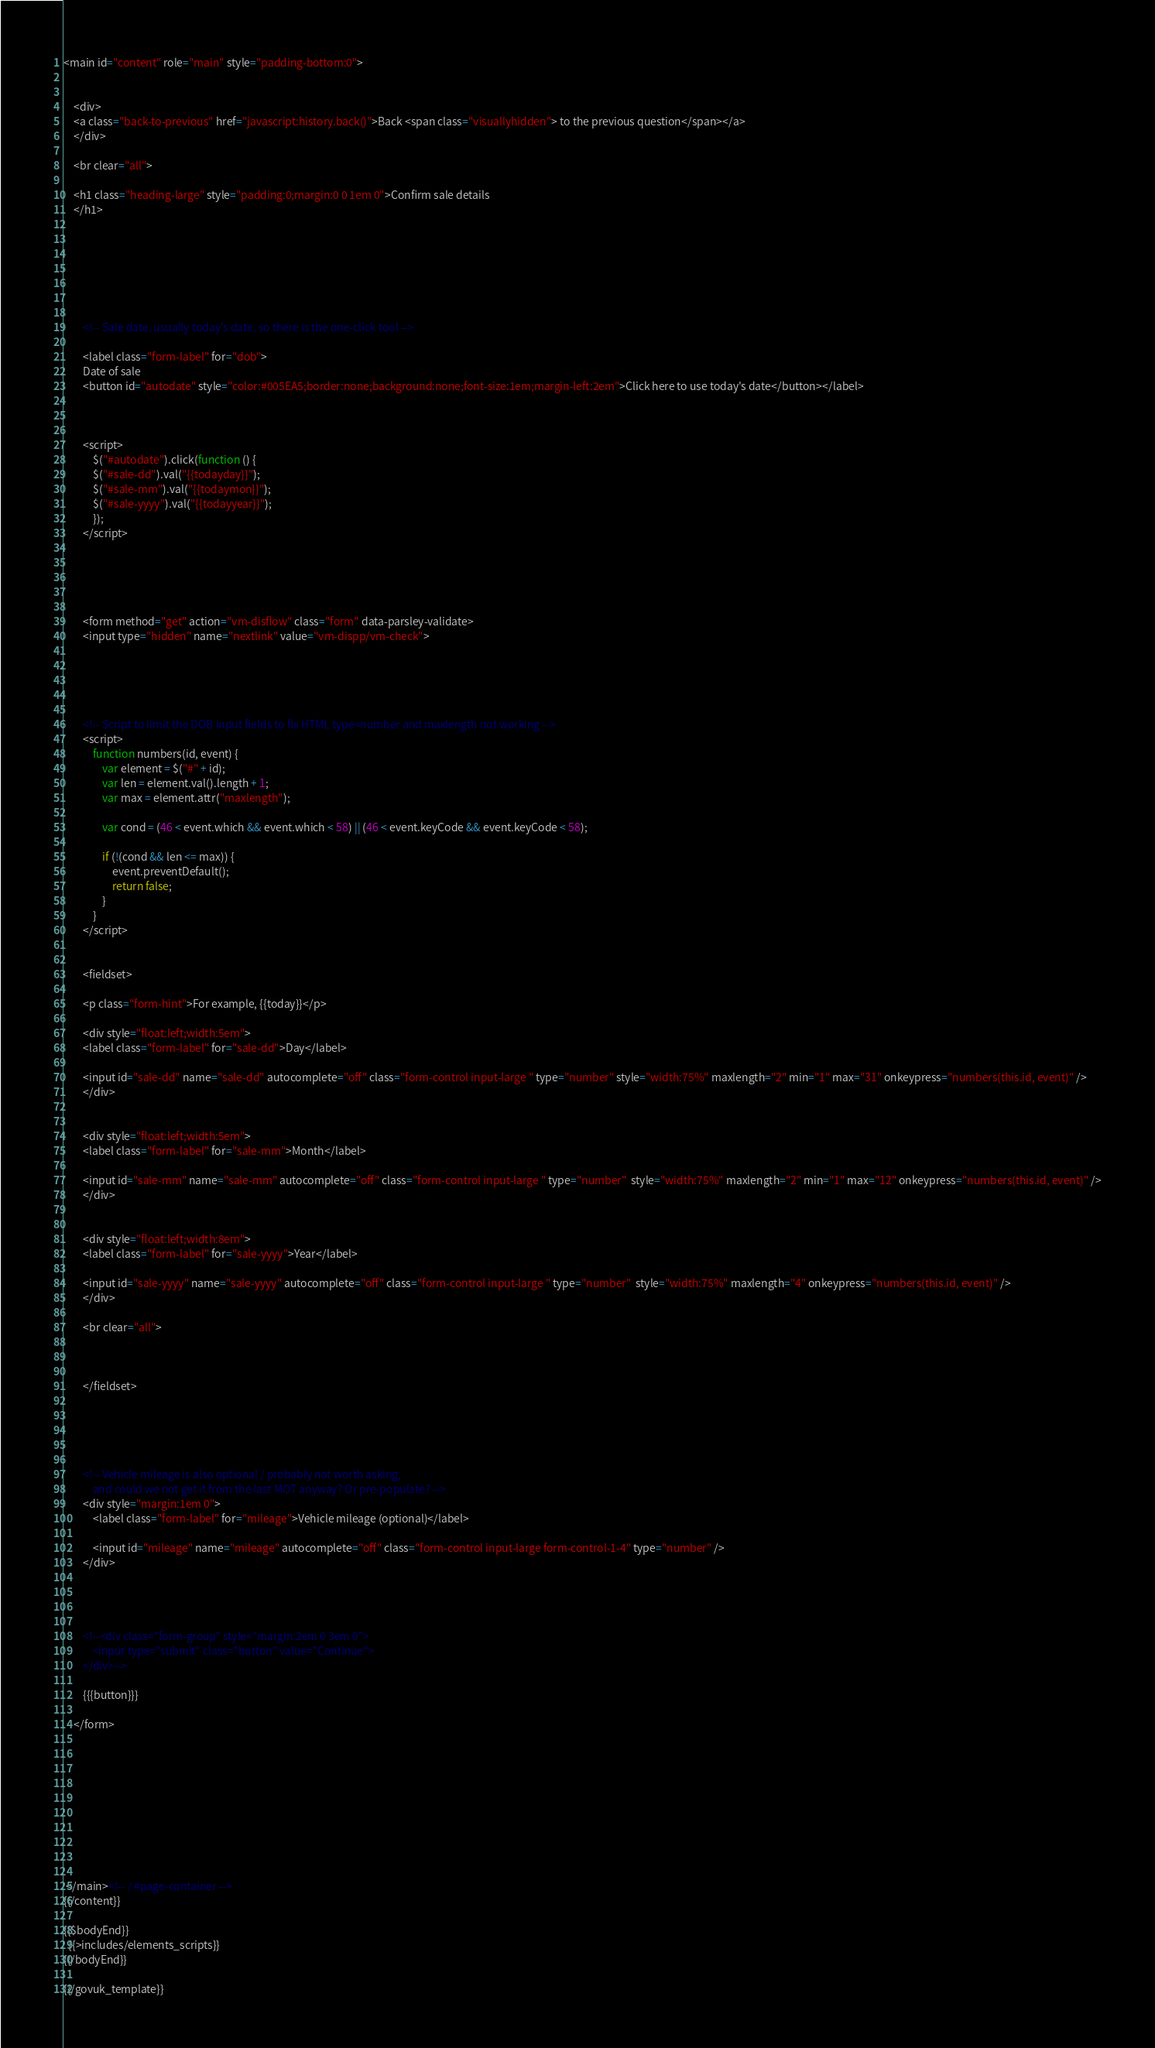<code> <loc_0><loc_0><loc_500><loc_500><_HTML_><main id="content" role="main" style="padding-bottom:0">


	<div>
	<a class="back-to-previous" href="javascript:history.back()">Back <span class="visuallyhidden"> to the previous question</span></a>
	</div>

	<br clear="all">

	<h1 class="heading-large" style="padding:0;margin:0 0 1em 0">Confirm sale details
	</h1>







		<!-- Sale date, usually today's date, so there is the one-click tool -->

		<label class="form-label" for="dob">
		Date of sale
		<button id="autodate" style="color:#005EA5;border:none;background:none;font-size:1em;margin-left:2em">Click here to use today's date</button></label>

		

		<script>
			$("#autodate").click(function () {
			$("#sale-dd").val("{{todayday}}");
			$("#sale-mm").val("{{todaymon}}");
			$("#sale-yyyy").val("{{todayyear}}");
			});
		</script>





		<form method="get" action="vm-disflow" class="form" data-parsley-validate>
		<input type="hidden" name="nextlink" value="vm-dispp/vm-check">
	   
	 
	 


		<!-- Script to limit the DOB input fields to fix HTML type=number and maxlength not working -->
		<script>
            function numbers(id, event) {
                var element = $("#" + id);
                var len = element.val().length + 1;
                var max = element.attr("maxlength");

                var cond = (46 < event.which && event.which < 58) || (46 < event.keyCode && event.keyCode < 58);

                if (!(cond && len <= max)) {
                    event.preventDefault();
                    return false;
                }
            }
        </script>


		<fieldset>

		<p class="form-hint">For example, {{today}}</p>

		<div style="float:left;width:5em">
		<label class="form-label" for="sale-dd">Day</label>

		<input id="sale-dd" name="sale-dd" autocomplete="off" class="form-control input-large " type="number" style="width:75%" maxlength="2" min="1" max="31" onkeypress="numbers(this.id, event)" />
		</div>


		<div style="float:left;width:5em">
		<label class="form-label" for="sale-mm">Month</label>

		<input id="sale-mm" name="sale-mm" autocomplete="off" class="form-control input-large " type="number"  style="width:75%" maxlength="2" min="1" max="12" onkeypress="numbers(this.id, event)" />
		</div>


		<div style="float:left;width:8em">
		<label class="form-label" for="sale-yyyy">Year</label>

		<input id="sale-yyyy" name="sale-yyyy" autocomplete="off" class="form-control input-large " type="number"  style="width:75%" maxlength="4" onkeypress="numbers(this.id, event)" />
		</div>

		<br clear="all">
		


		</fieldset>





	    <!-- Vehicle mileage is also optional / probably not worth asking,
	    	and could we not get it from the last MOT anyway? Or pre-populate? -->
	    <div style="margin:1em 0">
		    <label class="form-label" for="mileage">Vehicle mileage (optional)</label>

			<input id="mileage" name="mileage" autocomplete="off" class="form-control input-large form-control-1-4" type="number" />
		</div>




		<!--<div class="form-group" style="margin:2em 0 3em 0">
			<input type="submit" class="button" value="Continue">
        </div>-->

        {{{button}}}

    </form>

		





	

   
 </main><!-- / #page-container -->
{{/content}}

{{$bodyEnd}}
  {{>includes/elements_scripts}}
{{/bodyEnd}}

{{/govuk_template}}
</code> 